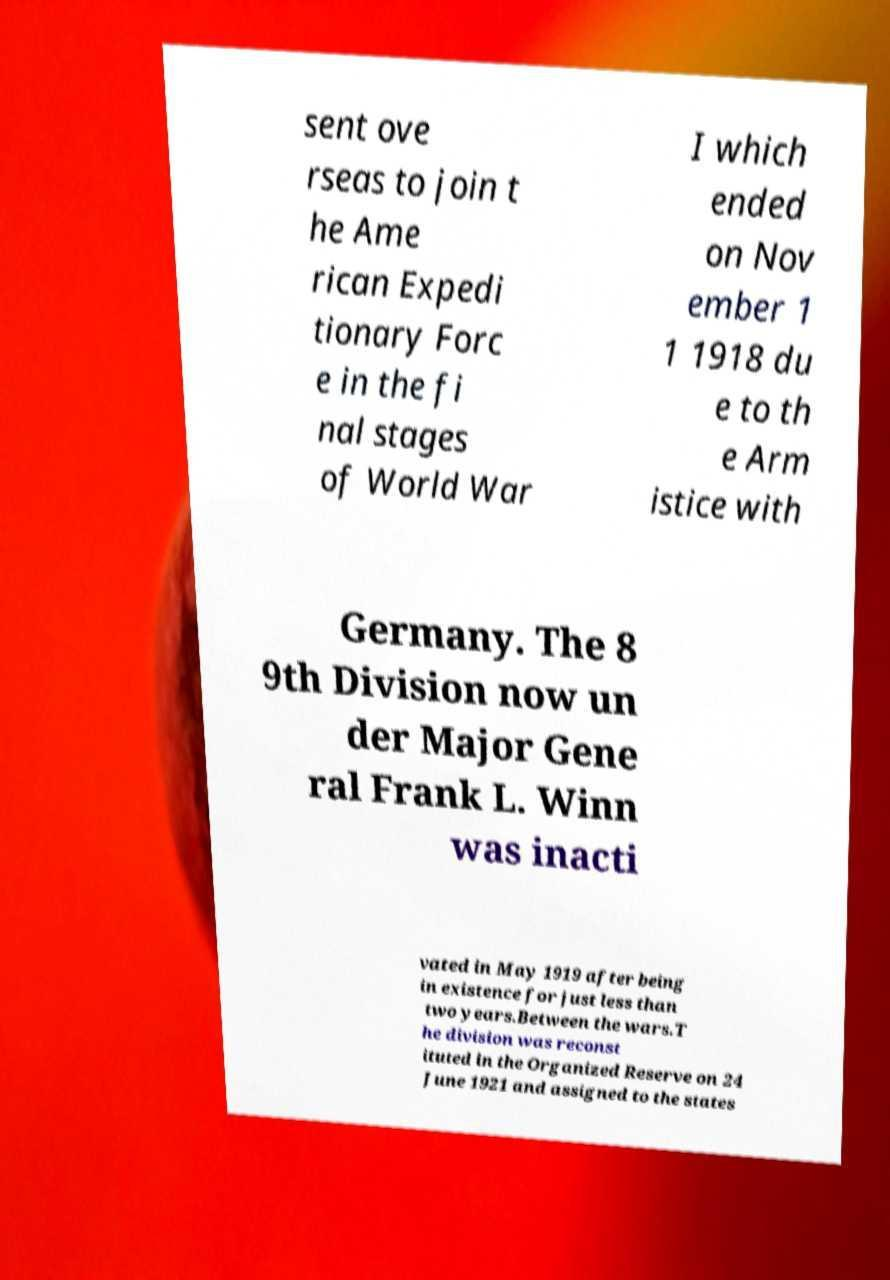Could you extract and type out the text from this image? sent ove rseas to join t he Ame rican Expedi tionary Forc e in the fi nal stages of World War I which ended on Nov ember 1 1 1918 du e to th e Arm istice with Germany. The 8 9th Division now un der Major Gene ral Frank L. Winn was inacti vated in May 1919 after being in existence for just less than two years.Between the wars.T he division was reconst ituted in the Organized Reserve on 24 June 1921 and assigned to the states 